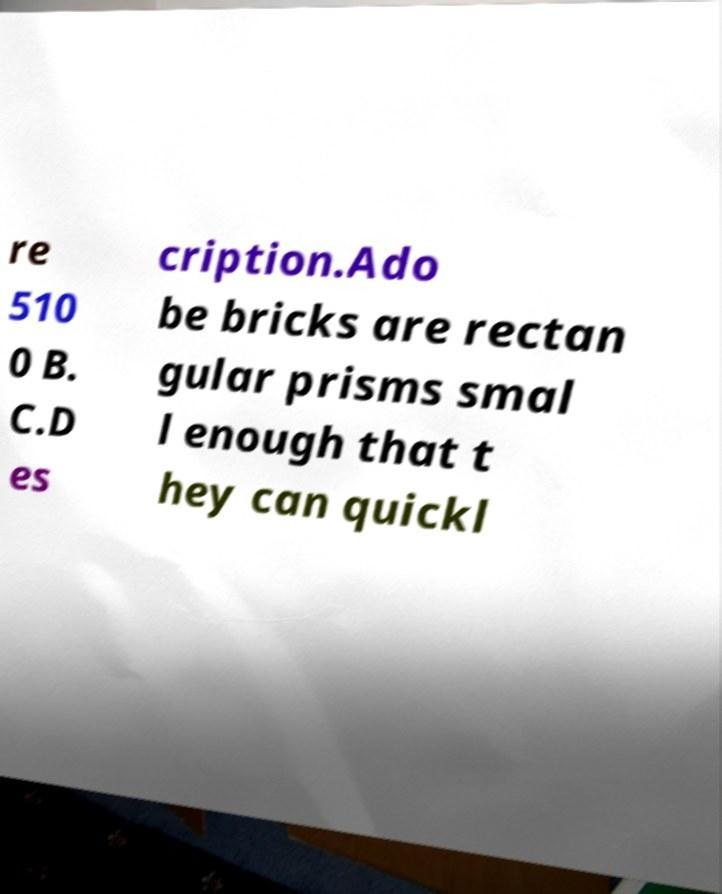Can you read and provide the text displayed in the image?This photo seems to have some interesting text. Can you extract and type it out for me? re 510 0 B. C.D es cription.Ado be bricks are rectan gular prisms smal l enough that t hey can quickl 